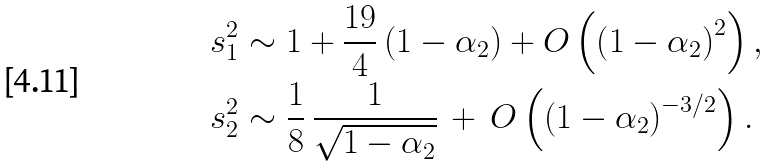Convert formula to latex. <formula><loc_0><loc_0><loc_500><loc_500>s _ { 1 } ^ { 2 } & \sim 1 + \frac { 1 9 } { 4 } \left ( 1 - \alpha _ { 2 } \right ) + O \left ( \left ( 1 - \alpha _ { 2 } \right ) ^ { 2 } \right ) , \\ s _ { 2 } ^ { 2 } & \sim \frac { 1 } { 8 } \, \frac { 1 } { \sqrt { 1 - \alpha _ { 2 } } } \, + \, O \left ( \left ( 1 - \alpha _ { 2 } \right ) ^ { - 3 / 2 } \right ) .</formula> 